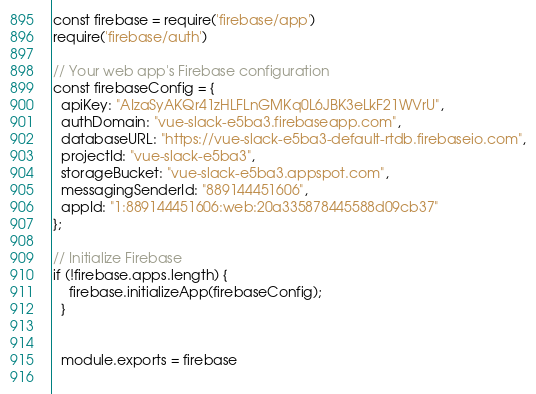<code> <loc_0><loc_0><loc_500><loc_500><_JavaScript_>const firebase = require('firebase/app')
require('firebase/auth')

// Your web app's Firebase configuration
const firebaseConfig = {
  apiKey: "AIzaSyAKQr41zHLFLnGMKq0L6JBK3eLkF21WVrU",
  authDomain: "vue-slack-e5ba3.firebaseapp.com",
  databaseURL: "https://vue-slack-e5ba3-default-rtdb.firebaseio.com",
  projectId: "vue-slack-e5ba3",
  storageBucket: "vue-slack-e5ba3.appspot.com",
  messagingSenderId: "889144451606",
  appId: "1:889144451606:web:20a335878445588d09cb37"
};

// Initialize Firebase
if (!firebase.apps.length) {
    firebase.initializeApp(firebaseConfig);
  }
  
  
  module.exports = firebase
  </code> 